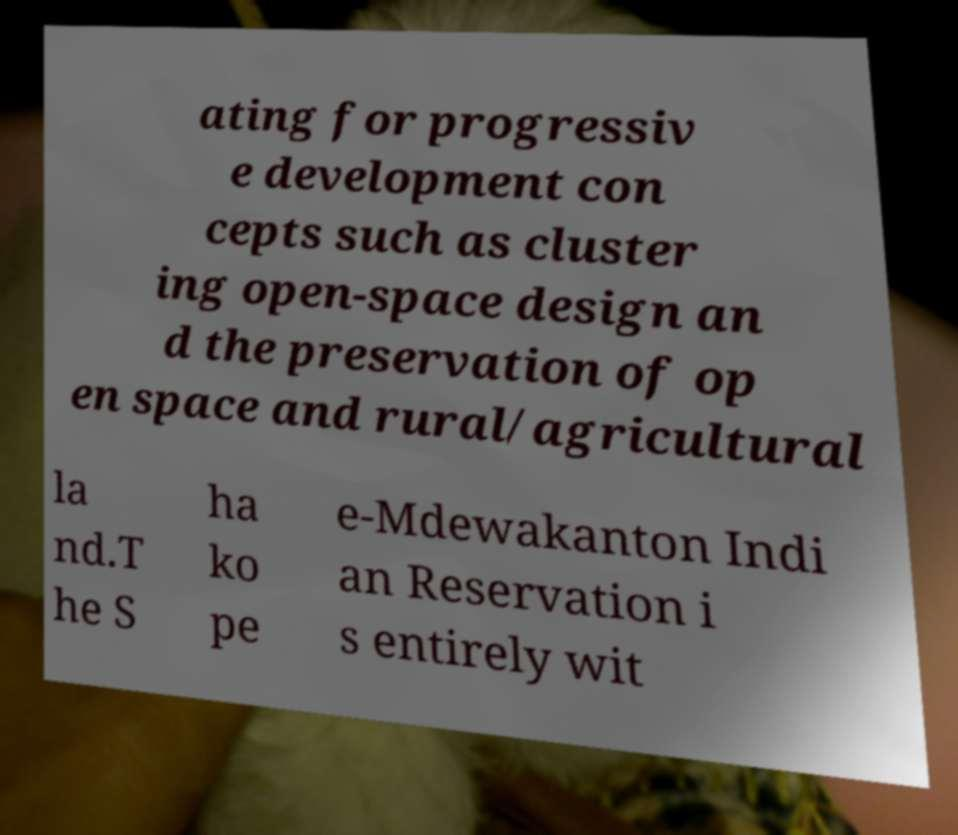Please identify and transcribe the text found in this image. ating for progressiv e development con cepts such as cluster ing open-space design an d the preservation of op en space and rural/agricultural la nd.T he S ha ko pe e-Mdewakanton Indi an Reservation i s entirely wit 